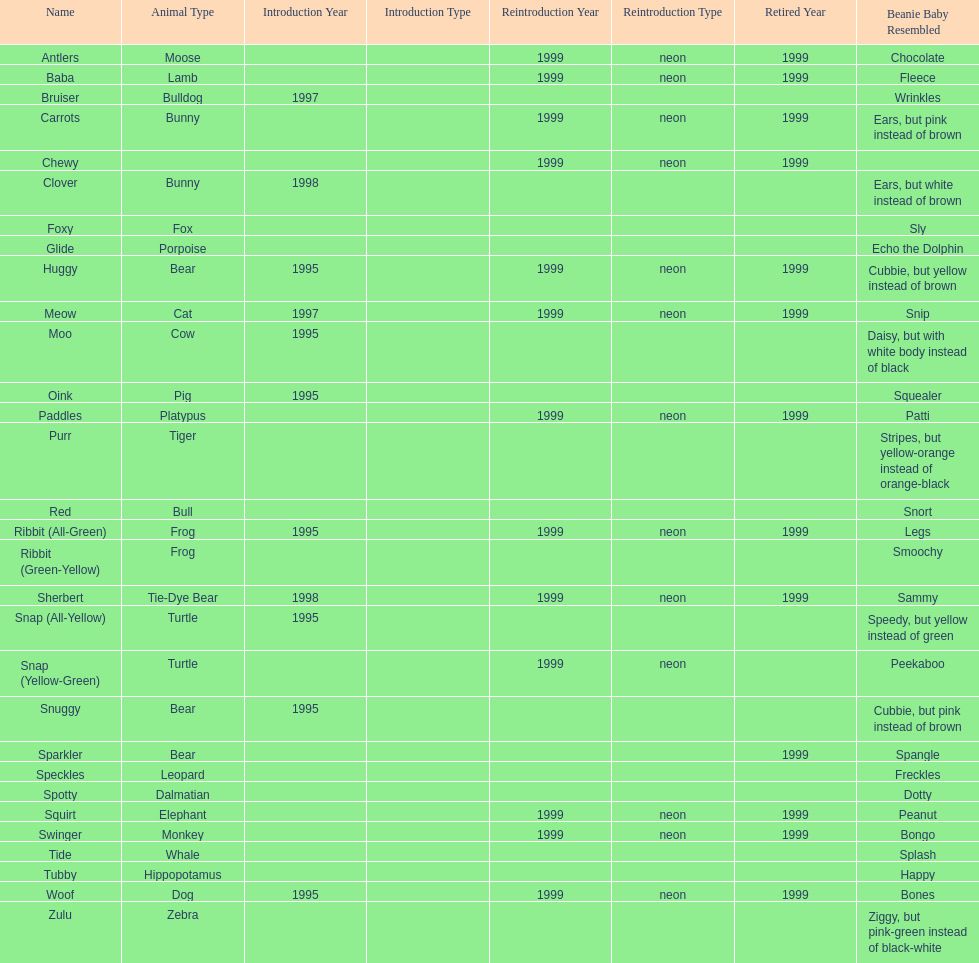Give me the full table as a dictionary. {'header': ['Name', 'Animal Type', 'Introduction Year', 'Introduction Type', 'Reintroduction Year', 'Reintroduction Type', 'Retired Year', 'Beanie Baby Resembled'], 'rows': [['Antlers', 'Moose', '', '', '1999', 'neon', '1999', 'Chocolate'], ['Baba', 'Lamb', '', '', '1999', 'neon', '1999', 'Fleece'], ['Bruiser', 'Bulldog', '1997', '', '', '', '', 'Wrinkles'], ['Carrots', 'Bunny', '', '', '1999', 'neon', '1999', 'Ears, but pink instead of brown'], ['Chewy', '', '', '', '1999', 'neon', '1999', ''], ['Clover', 'Bunny', '1998', '', '', '', '', 'Ears, but white instead of brown'], ['Foxy', 'Fox', '', '', '', '', '', 'Sly'], ['Glide', 'Porpoise', '', '', '', '', '', 'Echo the Dolphin'], ['Huggy', 'Bear', '1995', '', '1999', 'neon', '1999', 'Cubbie, but yellow instead of brown'], ['Meow', 'Cat', '1997', '', '1999', 'neon', '1999', 'Snip'], ['Moo', 'Cow', '1995', '', '', '', '', 'Daisy, but with white body instead of black'], ['Oink', 'Pig', '1995', '', '', '', '', 'Squealer'], ['Paddles', 'Platypus', '', '', '1999', 'neon', '1999', 'Patti'], ['Purr', 'Tiger', '', '', '', '', '', 'Stripes, but yellow-orange instead of orange-black'], ['Red', 'Bull', '', '', '', '', '', 'Snort'], ['Ribbit (All-Green)', 'Frog', '1995', '', '1999', 'neon', '1999', 'Legs'], ['Ribbit (Green-Yellow)', 'Frog', '', '', '', '', '', 'Smoochy'], ['Sherbert', 'Tie-Dye Bear', '1998', '', '1999', 'neon', '1999', 'Sammy'], ['Snap (All-Yellow)', 'Turtle', '1995', '', '', '', '', 'Speedy, but yellow instead of green'], ['Snap (Yellow-Green)', 'Turtle', '', '', '1999', 'neon', '', 'Peekaboo'], ['Snuggy', 'Bear', '1995', '', '', '', '', 'Cubbie, but pink instead of brown'], ['Sparkler', 'Bear', '', '', '', '', '1999', 'Spangle'], ['Speckles', 'Leopard', '', '', '', '', '', 'Freckles'], ['Spotty', 'Dalmatian', '', '', '', '', '', 'Dotty'], ['Squirt', 'Elephant', '', '', '1999', 'neon', '1999', 'Peanut'], ['Swinger', 'Monkey', '', '', '1999', 'neon', '1999', 'Bongo'], ['Tide', 'Whale', '', '', '', '', '', 'Splash'], ['Tubby', 'Hippopotamus', '', '', '', '', '', 'Happy'], ['Woof', 'Dog', '1995', '', '1999', 'neon', '1999', 'Bones'], ['Zulu', 'Zebra', '', '', '', '', '', 'Ziggy, but pink-green instead of black-white']]} Tell me the number of pillow pals reintroduced in 1999. 13. 